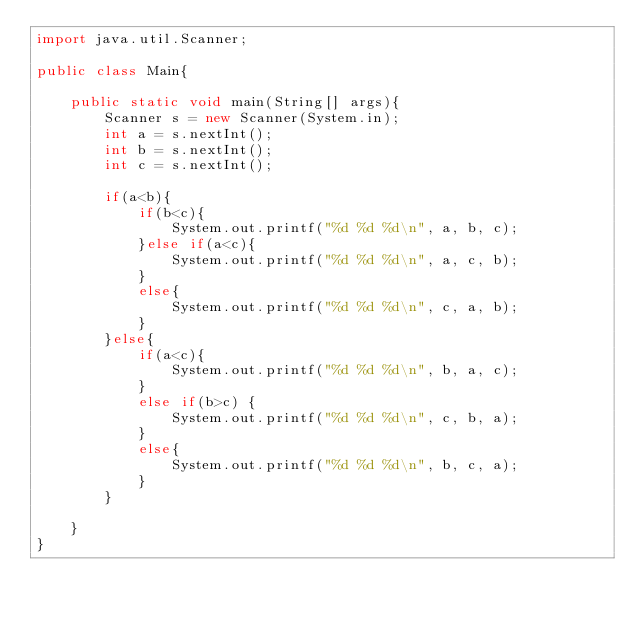Convert code to text. <code><loc_0><loc_0><loc_500><loc_500><_Java_>import java.util.Scanner;

public class Main{

	public static void main(String[] args){
		Scanner s = new Scanner(System.in);
		int a = s.nextInt();
		int b = s.nextInt();
		int c = s.nextInt();

		if(a<b){
			if(b<c){
				System.out.printf("%d %d %d\n", a, b, c);
			}else if(a<c){
				System.out.printf("%d %d %d\n", a, c, b);
			}
			else{
				System.out.printf("%d %d %d\n", c, a, b);
			}
		}else{
			if(a<c){
				System.out.printf("%d %d %d\n", b, a, c);
			}
			else if(b>c) { 
				System.out.printf("%d %d %d\n", c, b, a);
			}
			else{
				System.out.printf("%d %d %d\n", b, c, a);
			}
		}

	}
}</code> 